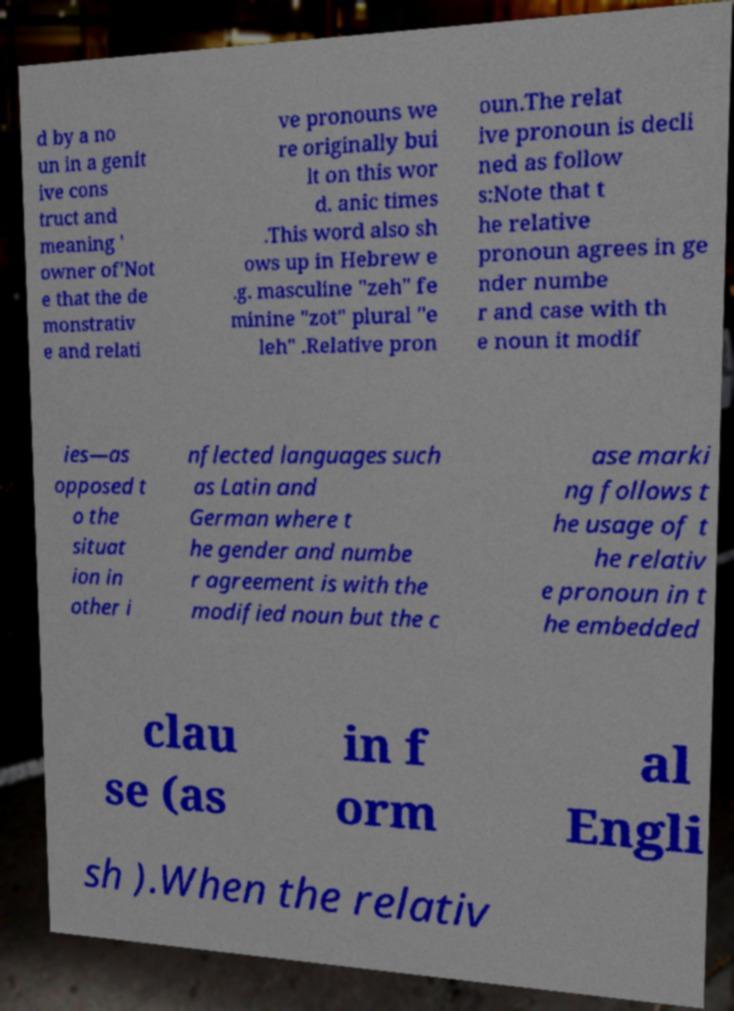There's text embedded in this image that I need extracted. Can you transcribe it verbatim? d by a no un in a genit ive cons truct and meaning ' owner of'Not e that the de monstrativ e and relati ve pronouns we re originally bui lt on this wor d. anic times .This word also sh ows up in Hebrew e .g. masculine "zeh" fe minine "zot" plural "e leh" .Relative pron oun.The relat ive pronoun is decli ned as follow s:Note that t he relative pronoun agrees in ge nder numbe r and case with th e noun it modif ies—as opposed t o the situat ion in other i nflected languages such as Latin and German where t he gender and numbe r agreement is with the modified noun but the c ase marki ng follows t he usage of t he relativ e pronoun in t he embedded clau se (as in f orm al Engli sh ).When the relativ 